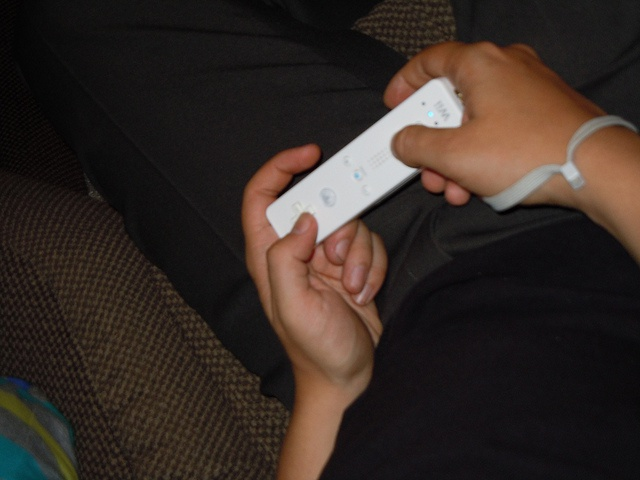Describe the objects in this image and their specific colors. I can see people in black, brown, and lightgray tones and remote in black, lightgray, darkgray, and gray tones in this image. 